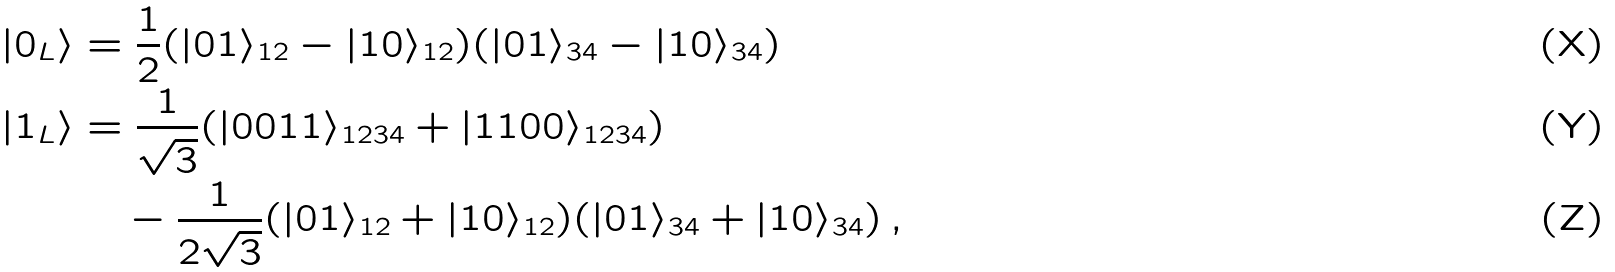Convert formula to latex. <formula><loc_0><loc_0><loc_500><loc_500>| 0 _ { L } \rangle & = \frac { 1 } { 2 } ( | 0 1 \rangle _ { 1 2 } - | 1 0 \rangle _ { 1 2 } ) ( | 0 1 \rangle _ { 3 4 } - | 1 0 \rangle _ { 3 4 } ) \\ | 1 _ { L } \rangle & = \frac { 1 } { \sqrt { 3 } } ( | 0 0 1 1 \rangle _ { 1 2 3 4 } + | 1 1 0 0 \rangle _ { 1 2 3 4 } ) \\ & \quad - \frac { 1 } { 2 \sqrt { 3 } } ( | 0 1 \rangle _ { 1 2 } + | 1 0 \rangle _ { 1 2 } ) ( | 0 1 \rangle _ { 3 4 } + | 1 0 \rangle _ { 3 4 } ) \, ,</formula> 